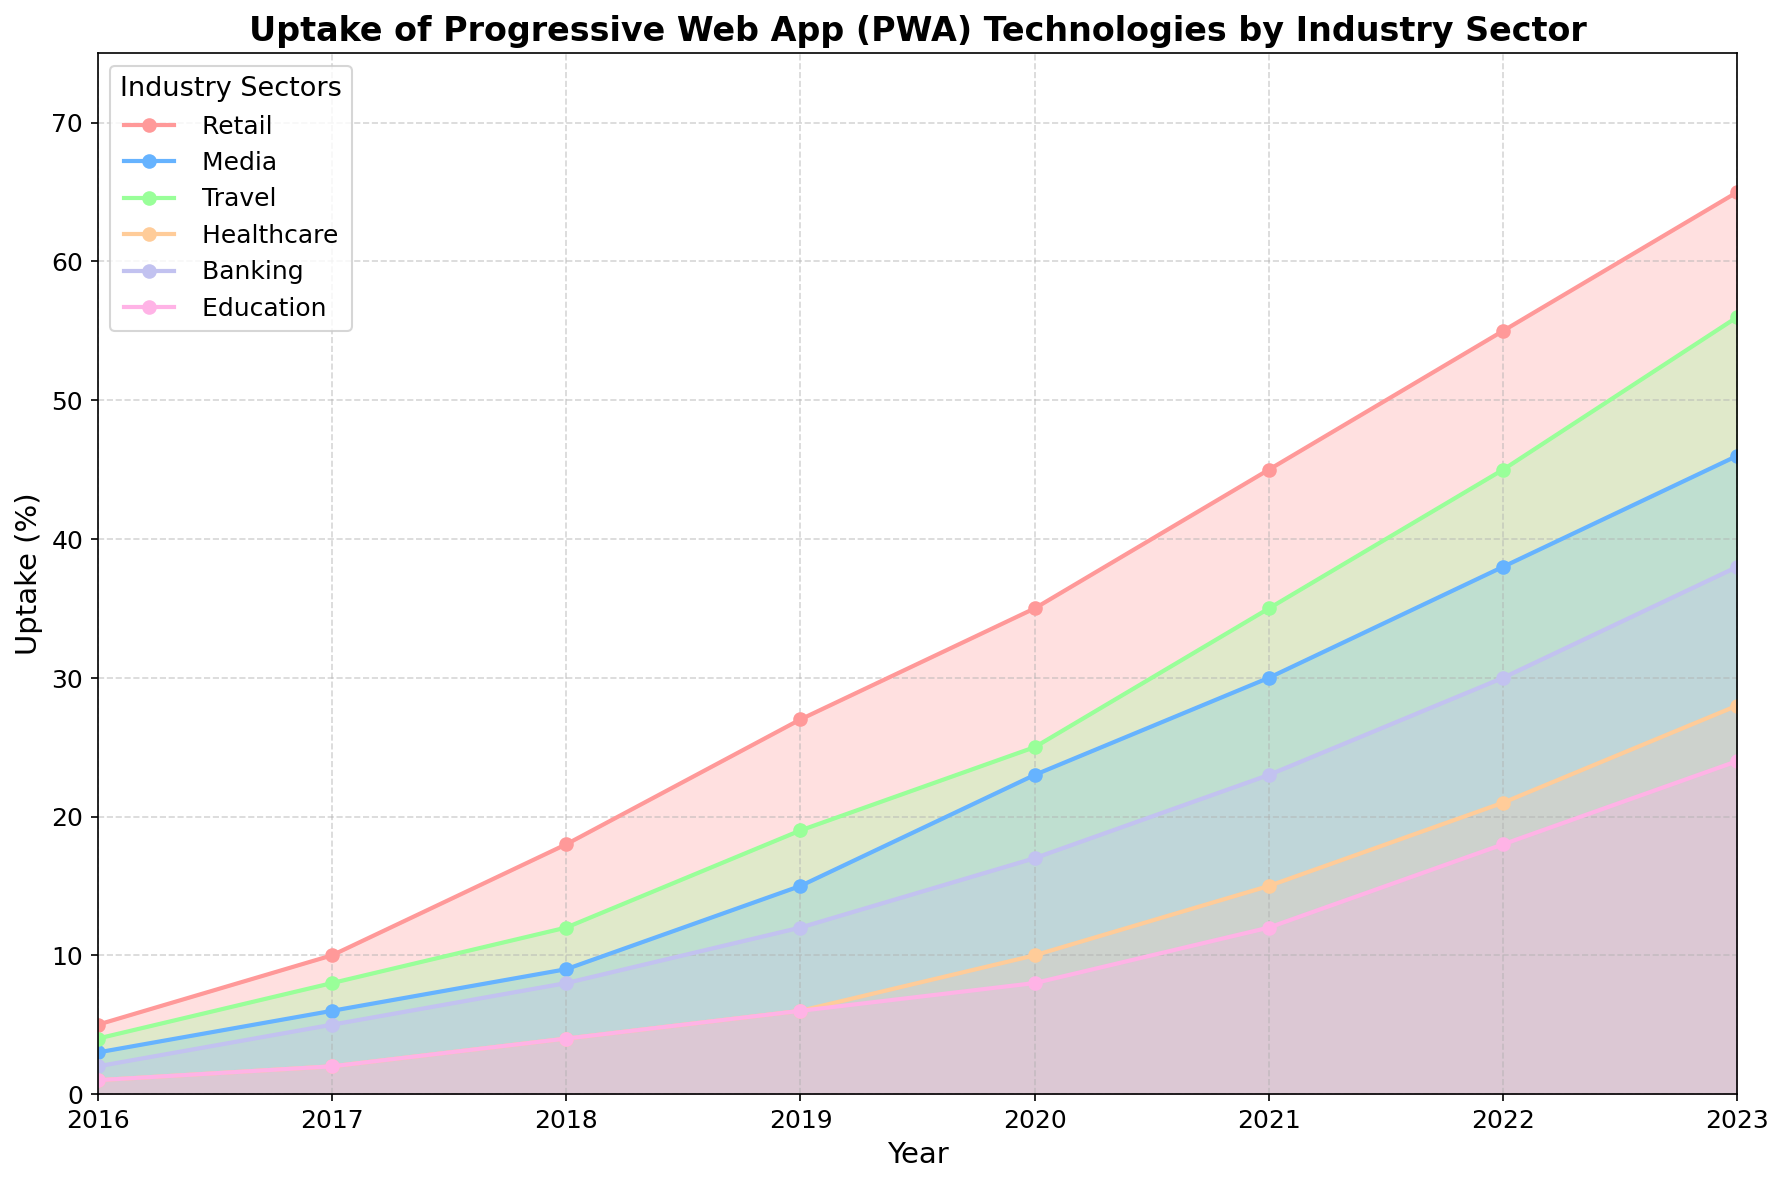What industry sector showed the highest PWA uptake in 2023? The figure shows the PWA uptake percentages for different industry sectors across the years. In 2023, the highest percentage can be identified by looking at the peak of the lines. Retail tops at 65%.
Answer: Retail Which two industry sectors had the closest adoption rates in 2019? In 2019, by examining the lines and their values, Media and Travel had values of 15% and 19% respectively, which are quite close.
Answer: Media and Travel What's the difference in PWA uptake between the Retail and Banking sectors in 2020? In the year 2020, the uptake for Retail is 35% while for Banking it's 17%. Subtracting these gives 35 - 17 = 18%.
Answer: 18% Between 2016 and 2023, how much did the uptake in the Healthcare sector increase? In 2016, Healthcare had an uptake of 1%. By 2023, this increased to 28%. The total increase is 28 - 1 = 27%.
Answer: 27% Which sector had the slowest growth rate in PWA uptake from 2016 to 2023? By comparing the differences between 2023 and 2016 across all sectors, Education increased from 1% to 24%, which is the slowest overall growth in terms of percentage points.
Answer: Education In which year did Travel surpass the Media industry in PWA uptake? By comparing the lines for the Travel and Media sectors each year, Travel surpassed Media in 2020 (Travel = 25% vs Media = 23%).
Answer: 2020 What's the average uptake of PWA technologies in the Banking sector over the years provided? Summing up the Banking sector uptake percentages across each year: 2+5+8+12+17+23+30+38 = 135. There are 8 years, so the average is 135/8 = 16.875%.
Answer: 16.9% How many sectors had an uptake of at least 20% by 2022? In 2022, checking the levels reached, Retail (55%), Media (38%), Travel (45%), Healthcare (21%), and Banking (30%) all crossed 20%. This totals to 5 sectors.
Answer: 5 Compare the uptake trends for Education and Retail. Who had a steeper increase? Retail starts at 5% in 2016 and reaches 65% in 2023, while Education goes from 1% to 24%. The increase for Retail is 65-5=60, and for Education, it's 24-1=23. Retail had a steeper increase (60 vs. 23).
Answer: Retail Which sector's uptake percentage more than doubled from 2018 to 2019? Observing the growth between 2018 and 2019, the Media sector jumped from 9% to 15%, which is less than double. However, the Retail sector grows from 18% to 27%, a less than double increase. Thus, no sector more than doubled its uptake.
Answer: None 